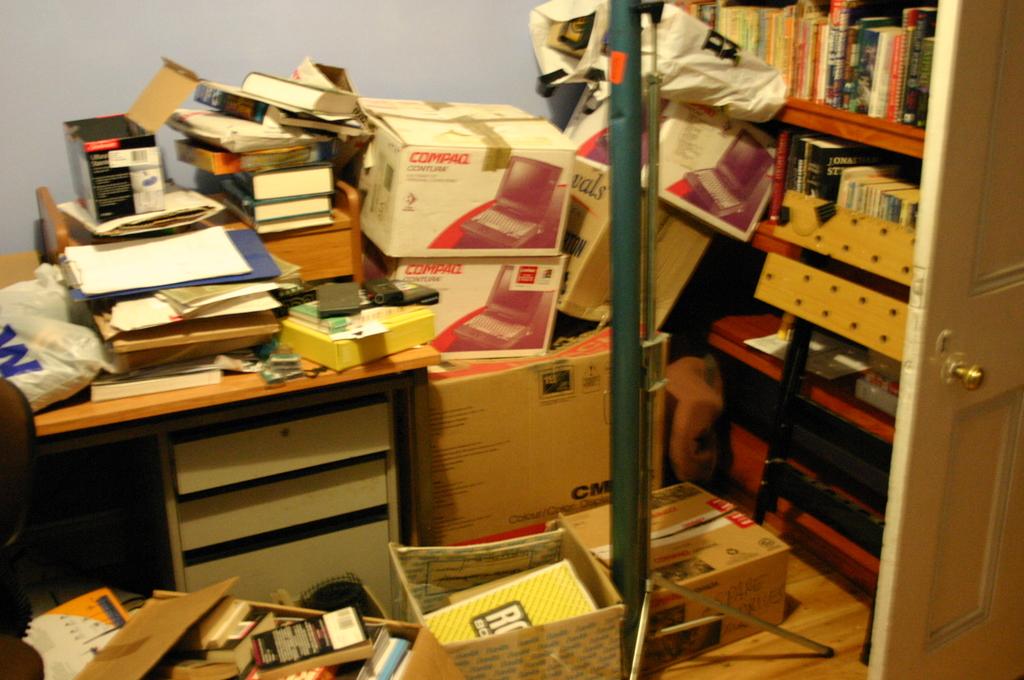What type of laptop is in the box?
Ensure brevity in your answer.  Compaq. What brand of computers are in the white boxes?
Provide a short and direct response. Compaq. 